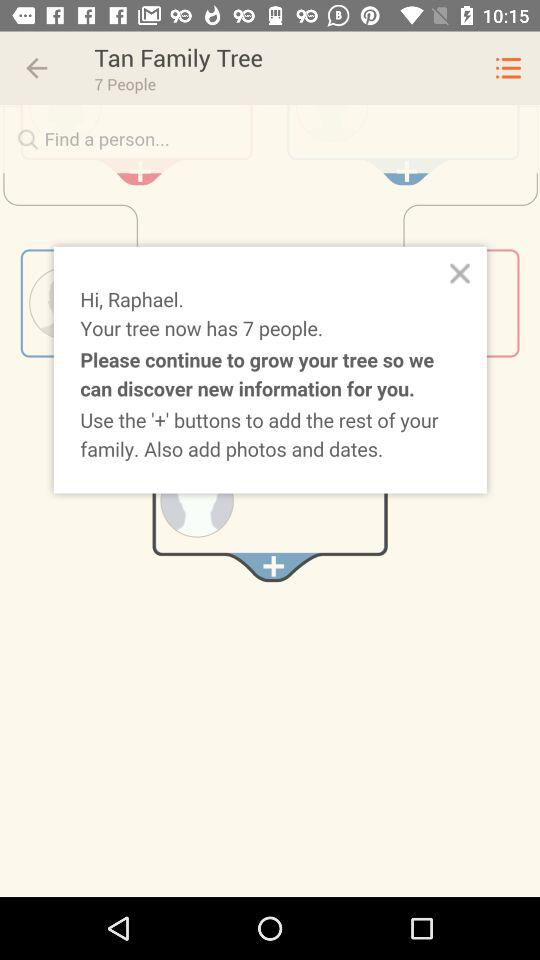What is the name of the user? The name of the user is Raphael. 